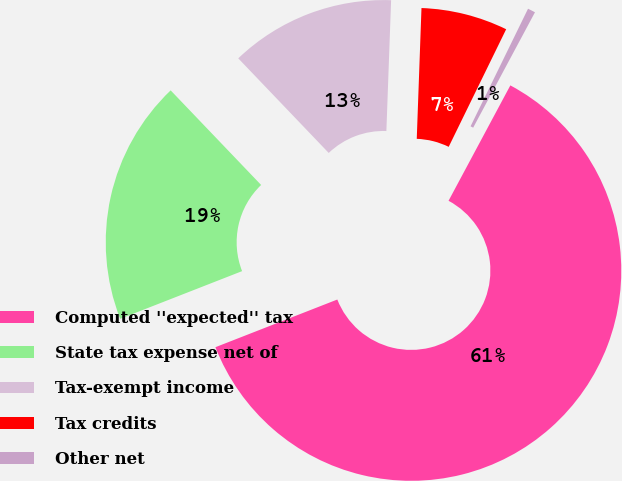Convert chart to OTSL. <chart><loc_0><loc_0><loc_500><loc_500><pie_chart><fcel>Computed ''expected'' tax<fcel>State tax expense net of<fcel>Tax-exempt income<fcel>Tax credits<fcel>Other net<nl><fcel>61.24%<fcel>18.79%<fcel>12.72%<fcel>6.66%<fcel>0.59%<nl></chart> 